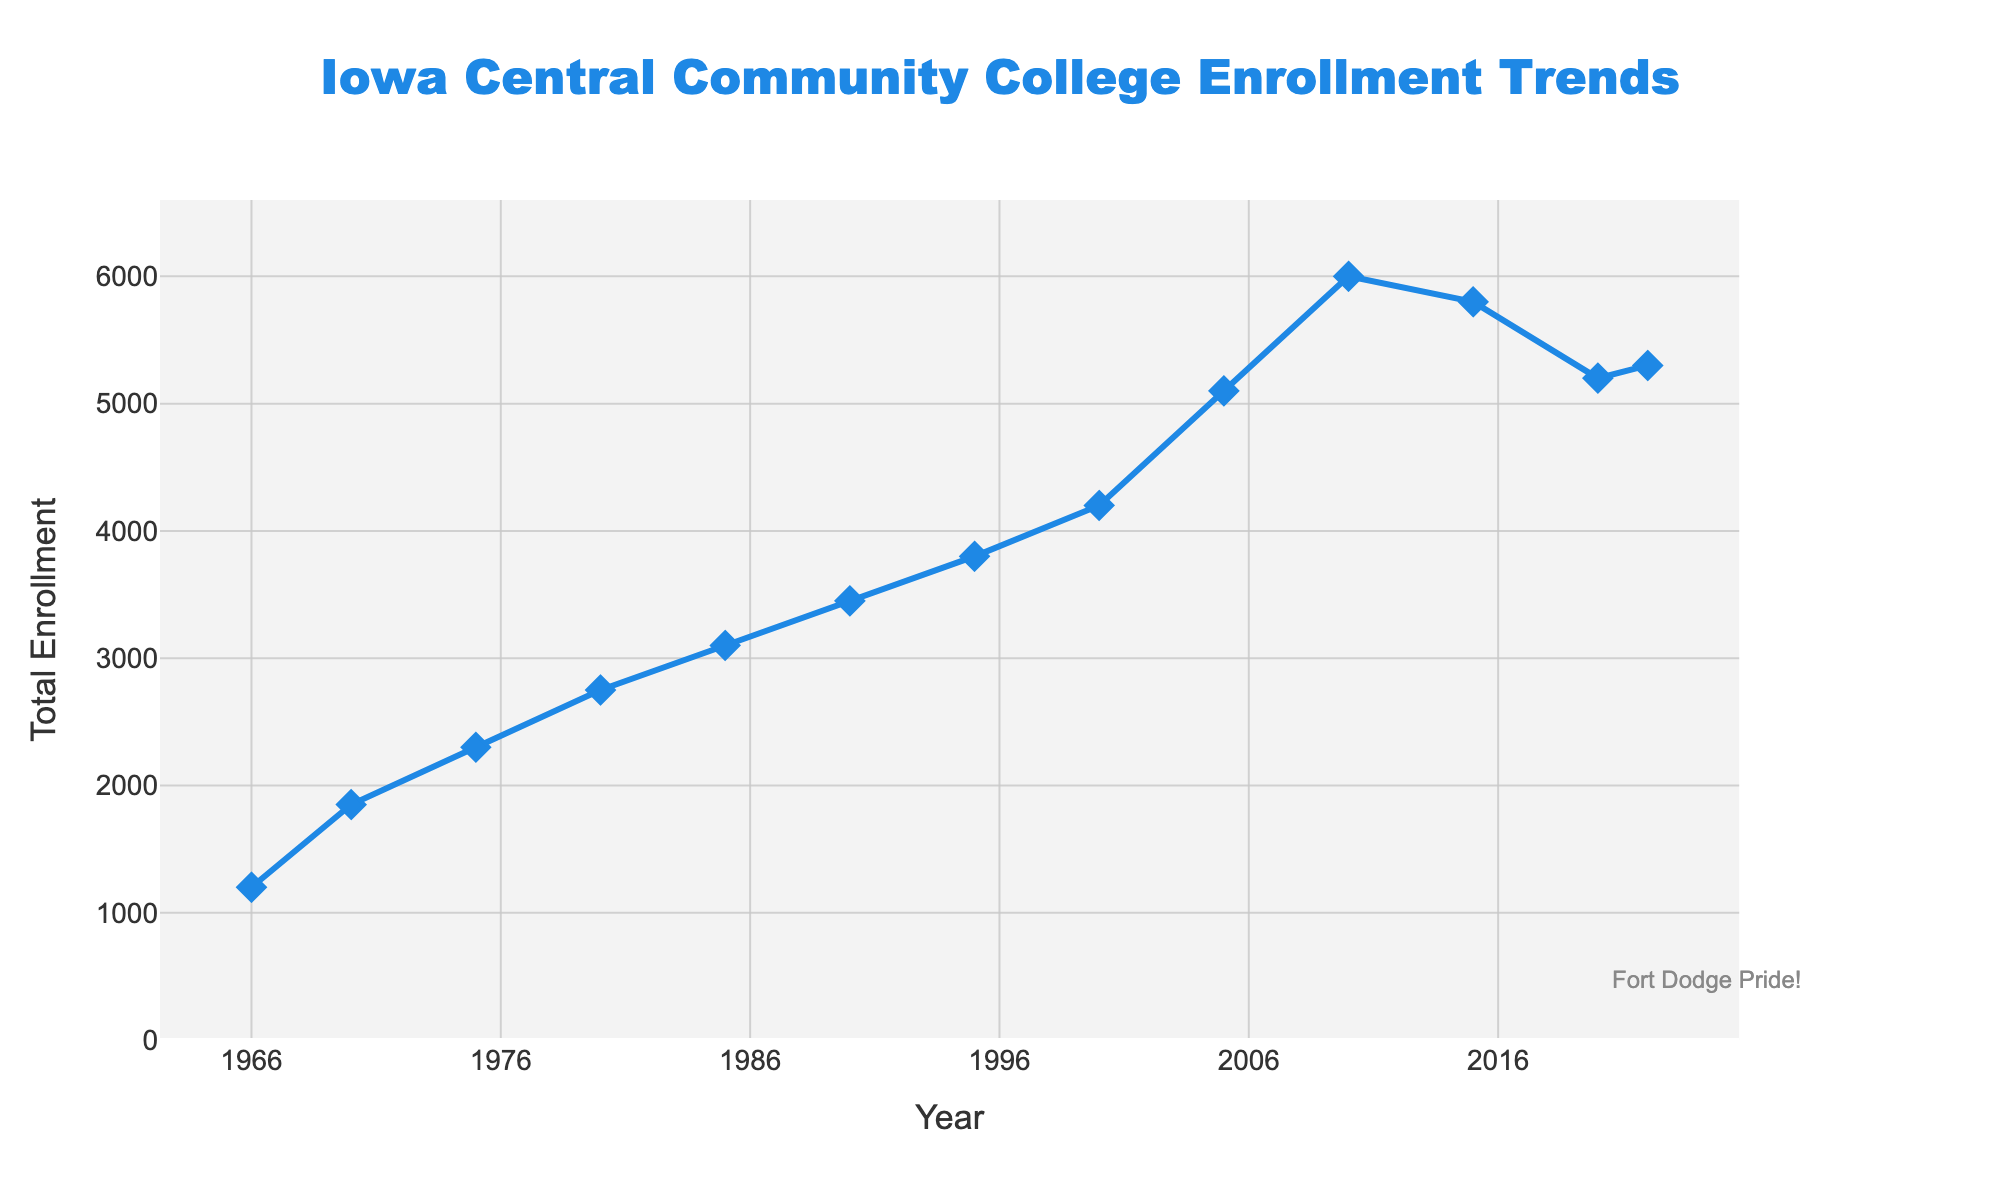What's the total increase in student enrollment from 1966 to 2022? To calculate the total increase, subtract the enrollment in 1966 from the enrollment in 2022. So, 5300 (2022) - 1200 (1966) = 4100.
Answer: 4100 What is the highest recorded student enrollment and in which year did it occur? The highest recorded enrollment is the peak value seen on the figure. It occurred in 2010 with an enrollment of 6000 students.
Answer: 6000, 2010 Between which two consecutive recorded years did student enrollment decrease the most, and by how much? To find the biggest decrease, look at the drops in enrollment between each pair of consecutive years. The largest decrease is between 2010 (6000) and 2015 (5800), with a change of 6000 - 5800 = 200.
Answer: 2010 and 2015, 200 What is the average annual enrollment over the span from 1966 to 2022? To find the average, calculate the total of all enrollments and divide by the number of years listed. Total = 1200 + 1850 + 2300 + 2750 + 3100 + 3450 + 3800 + 4200 + 5100 + 6000 + 5800 + 5200 + 5300 = 50050; Number of years = 13; Average = 50050 / 13 ≈ 3850.
Answer: 3850 How many times did the student enrollment surpass 5000? Count the points on the figure where the enrollment values are above 5000. These points are at years 2005, 2010, 2015, 2020, and 2022. That's 5 times.
Answer: 5 times Describe the overall trend in student enrollment at Iowa Central Community College from its founding to present day. The trend shows a general increase in student enrollment from 1200 in 1966 to a peak of 6000 in 2010, followed by a decrease to 5200 in 2020, then a slight increase to 5300 in 2022.
Answer: General increase, peaking at 2010, slight decrease after During which decade did Iowa Central Community College see the largest relative growth in student enrollment? Review each decade's growth by relative increase: 
1966-1970: (1850-1200)/1200 ≈ 54% 
1970-1980: (2750-1850)/1850 ≈ 49% 
1980-1990: (3450-2750)/2750 ≈ 25% 
1990-2000: (4200-3450)/3450 ≈ 22% 
2000-2010: (6000-4200)/4200 ≈ 43%
The largest relative growth occurred from 1966 to 1970.
Answer: 1966-1970 If the trend from 2005 to 2010 had continued, what would have been the projected enrollment in 2015? From 2005 (5100) to 2010 (6000), the increase was 900 in 5 years. Assuming a similar increase: 6000 + 900 = 6900 projected for 2015.
Answer: 6900 